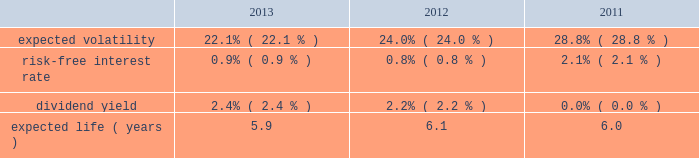Portion of the death benefits directly from the insurance company and the company receives the remainder of the death benefits .
It is currently expected that minimal cash payments will be required to fund these policies .
The net periodic pension cost for these split-dollar life insurance arrangements was $ 5 million for the years ended december 31 , 2013 , 2012 and 2011 .
The company has recorded a liability representing the actuarial present value of the future death benefits as of the employees 2019 expected retirement date of $ 51 million and $ 58 million as of december 31 , 2013 and december 31 , 2012 , respectively .
Deferred compensation plan the company amended and reinstated its deferred compensation plan ( 201cthe plan 201d ) effective june 1 , 2013 to reopen the plan to certain participants .
Under the plan , participating executives may elect to defer base salary and cash incentive compensation in excess of 401 ( k ) plan limitations .
Participants under the plan may choose to invest their deferred amounts in the same investment alternatives available under the company's 401 ( k ) plan .
The plan also allows for company matching contributions for the following : ( i ) the first 4% ( 4 % ) of compensation deferred under the plan , subject to a maximum of $ 50000 for board officers , ( ii ) lost matching amounts that would have been made under the 401 ( k ) plan if participants had not participated in the plan , and ( iii ) discretionary amounts as approved by the compensation and leadership committee of the board of directors .
Defined contribution plan the company and certain subsidiaries have various defined contribution plans , in which all eligible employees may participate .
In the u.s. , the 401 ( k ) plan is a contributory plan .
Matching contributions are based upon the amount of the employees 2019 contributions .
The company 2019s expenses for material defined contribution plans for the years ended december 31 , 2013 , 2012 and 2011 were $ 44 million , $ 42 million and $ 48 million , respectively .
Beginning january 1 , 2012 , the company may make an additional discretionary 401 ( k ) plan matching contribution to eligible employees .
For the years ended december 31 , 2013 and 2012 , the company made no discretionary matching contributions .
Share-based compensation plans and other incentive plans stock options , stock appreciation rights and employee stock purchase plan the company grants options to acquire shares of common stock to certain employees and to existing option holders of acquired companies in connection with the merging of option plans following an acquisition .
Each option granted and stock appreciation right has an exercise price of no less than 100% ( 100 % ) of the fair market value of the common stock on the date of the grant .
The awards have a contractual life of five to fifteen years and vest over two to four years .
Stock options and stock appreciation rights assumed or replaced with comparable stock options or stock appreciation rights in conjunction with a change in control of the company only become exercisable if the holder is also involuntarily terminated ( for a reason other than cause ) or quits for good reason within 24 months of a change in control .
The employee stock purchase plan allows eligible participants to purchase shares of the company 2019s common stock through payroll deductions of up to 20% ( 20 % ) of eligible compensation on an after-tax basis .
Plan participants cannot purchase more than $ 25000 of stock in any calendar year .
The price an employee pays per share is 85% ( 85 % ) of the lower of the fair market value of the company 2019s stock on the close of the first trading day or last trading day of the purchase period .
The plan has two purchase periods , the first from october 1 through march 31 and the second from april 1 through september 30 .
For the years ended december 31 , 2013 , 2012 and 2011 , employees purchased 1.5 million , 1.4 million and 2.2 million shares , respectively , at purchase prices of $ 43.02 and $ 50.47 , $ 34.52 and $ 42.96 , and $ 30.56 and $ 35.61 , respectively .
The company calculates the value of each employee stock option , estimated on the date of grant , using the black-scholes option pricing model .
The weighted-average estimated fair value of employee stock options granted during 2013 , 2012 and 2011 was $ 9.52 , $ 9.60 and $ 13.25 , respectively , using the following weighted-average assumptions: .
The company uses the implied volatility for traded options on the company 2019s stock as the expected volatility assumption required in the black-scholes model .
The selection of the implied volatility approach was based upon the availability of .
What was the average expected volatility from 2011 to 2013? 
Computations: (((22.1 + 24.0) + 28.8) / 3)
Answer: 24.96667. 